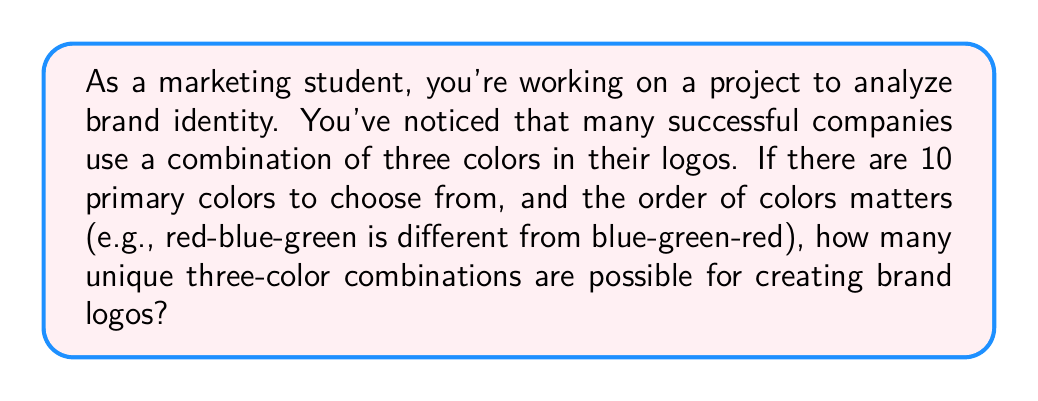Give your solution to this math problem. To solve this problem, we need to use the concept of permutations. Since the order of colors matters and we are selecting 3 colors out of 10 without replacement (we don't use the same color twice in a logo), this is a permutation problem.

The formula for permutations is:

$$P(n,r) = \frac{n!}{(n-r)!}$$

Where:
$n$ = total number of items to choose from
$r$ = number of items being chosen

In this case:
$n = 10$ (total number of primary colors)
$r = 3$ (number of colors used in each logo)

Plugging these values into the formula:

$$P(10,3) = \frac{10!}{(10-3)!} = \frac{10!}{7!}$$

Expanding this:

$$\frac{10 \times 9 \times 8 \times 7!}{7!}$$

The $7!$ cancels out in the numerator and denominator:

$$10 \times 9 \times 8 = 720$$

Therefore, there are 720 possible unique three-color combinations for creating brand logos.
Answer: 720 unique color combinations 